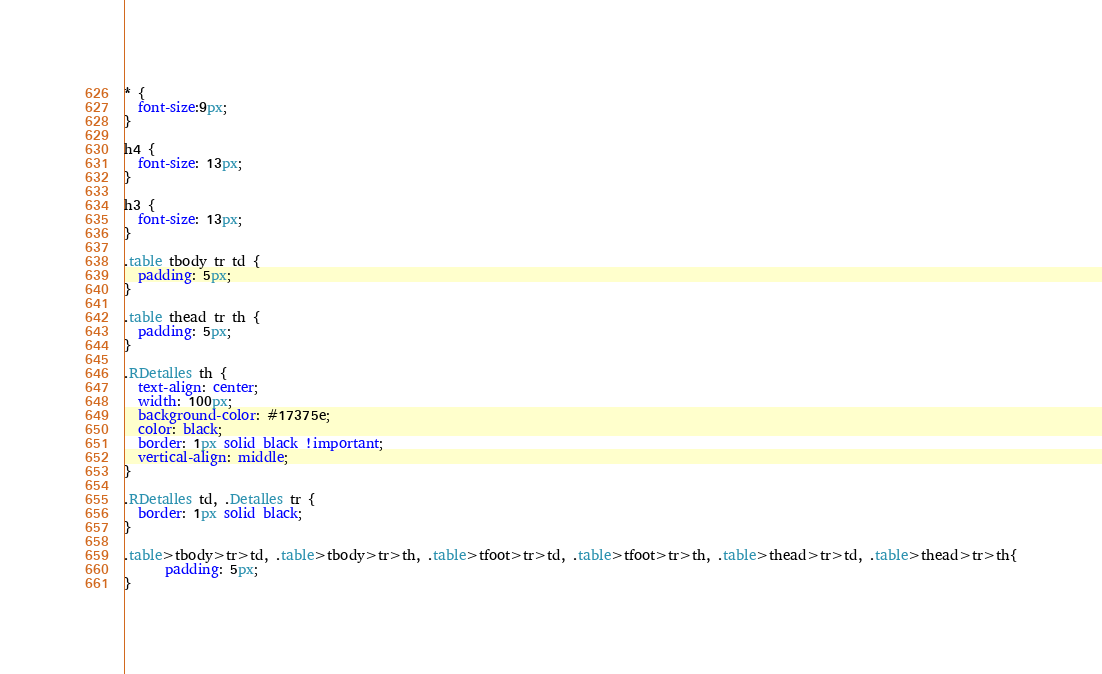<code> <loc_0><loc_0><loc_500><loc_500><_CSS_>* {
  font-size:9px;
}

h4 {
  font-size: 13px;
}

h3 {
  font-size: 13px;
}

.table tbody tr td {
  padding: 5px;
}

.table thead tr th {
  padding: 5px;
}

.RDetalles th {
  text-align: center;
  width: 100px;
  background-color: #17375e;
  color: black;
  border: 1px solid black !important;
  vertical-align: middle;
}

.RDetalles td, .Detalles tr {
  border: 1px solid black;
}

.table>tbody>tr>td, .table>tbody>tr>th, .table>tfoot>tr>td, .table>tfoot>tr>th, .table>thead>tr>td, .table>thead>tr>th{
      padding: 5px;
}
</code> 